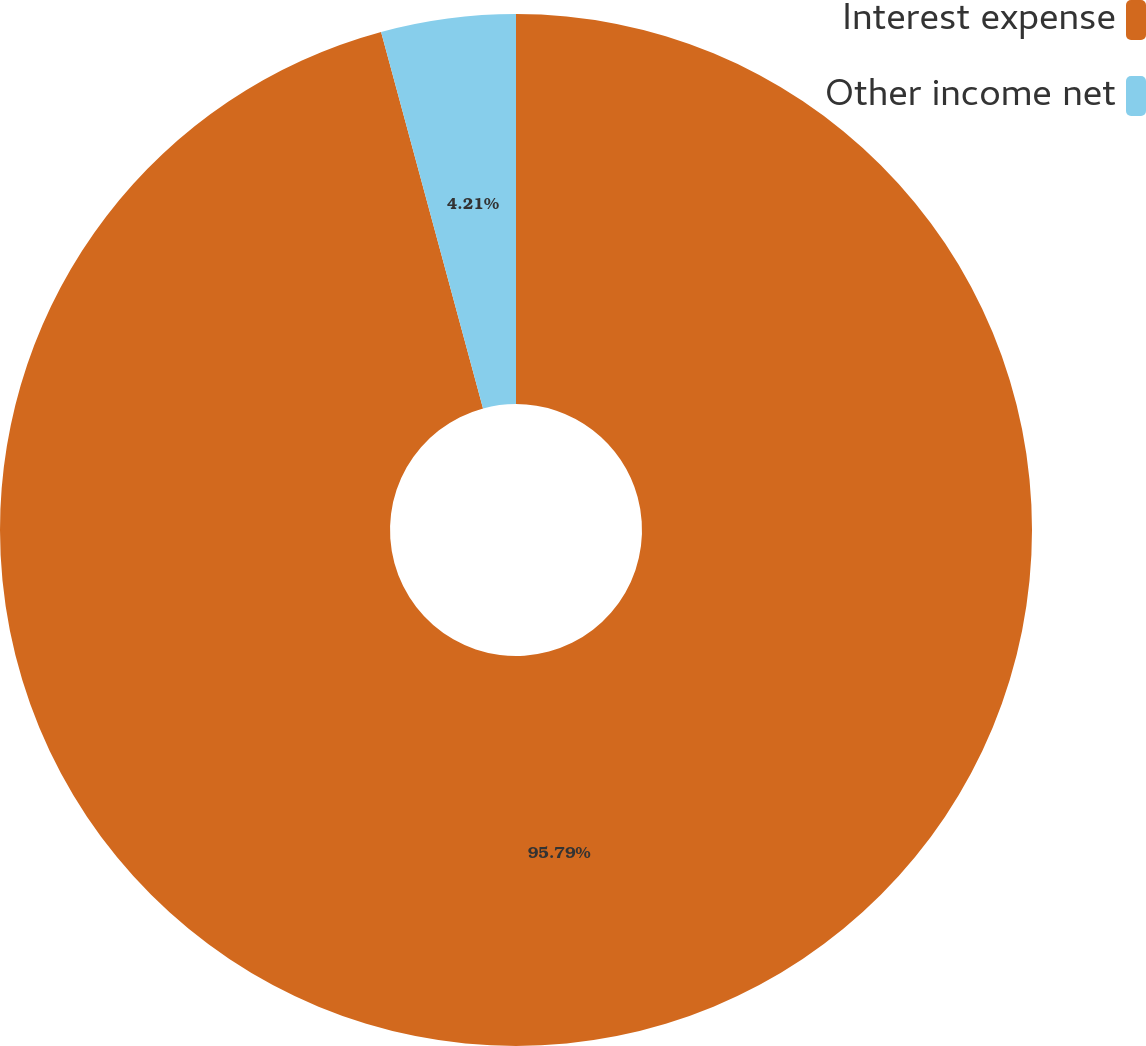Convert chart to OTSL. <chart><loc_0><loc_0><loc_500><loc_500><pie_chart><fcel>Interest expense<fcel>Other income net<nl><fcel>95.79%<fcel>4.21%<nl></chart> 